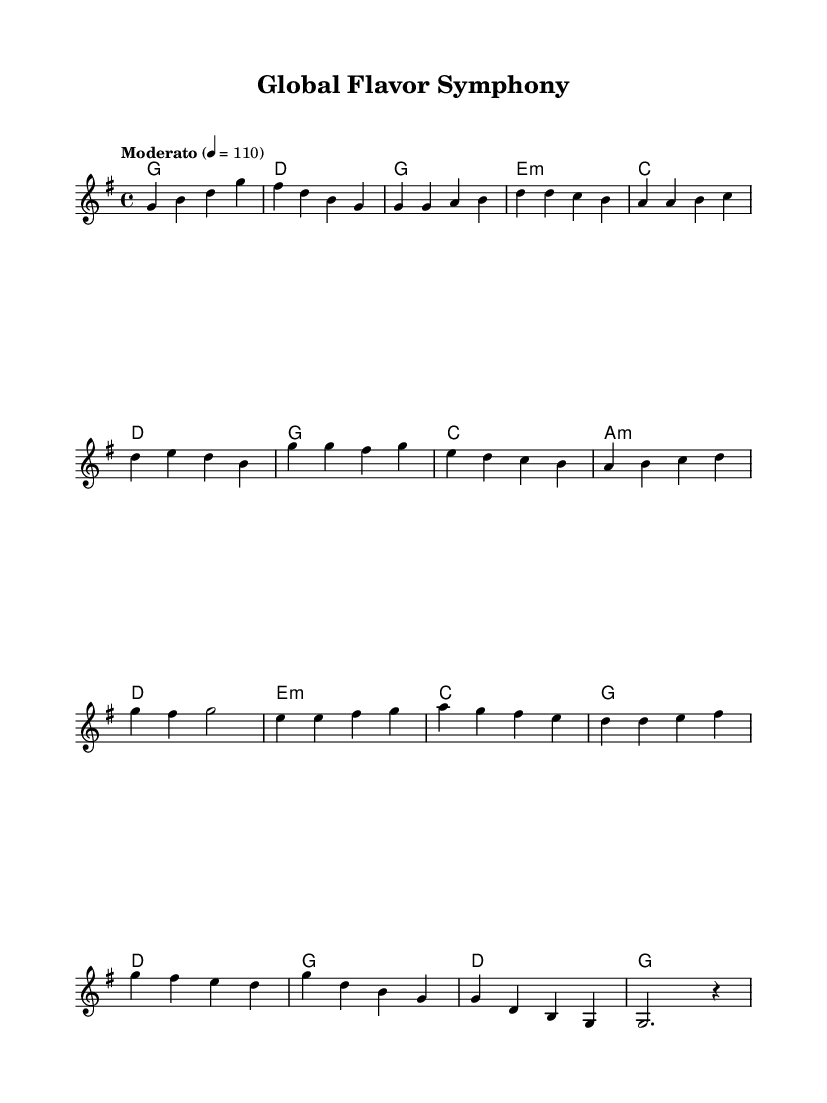What is the key signature of this music? The key signature is G major, which has one sharp (F#). You can identify this by looking at the beginning of the staff where the key signature is indicated.
Answer: G major What is the time signature of this music? The time signature is 4/4, which means there are four beats in a measure and a quarter note gets one beat. This can be observed at the beginning of the score, right after the key signature.
Answer: 4/4 What is the tempo marking for this piece? The tempo marking indicates "Moderato" with a metronome marking of 110 beats per minute. This is often shown in the score to indicate the speed at which the music should be played.
Answer: Moderato 110 How many measures are there in the chorus section? The chorus section consists of four measures, which can be counted by looking at the corresponding melody and harmony lines for that part of the song.
Answer: 4 What chord is played with the melody note 'e' in the bridge? The chord played with the melody note 'e' in the bridge is an E minor chord, which is indicated directly under the melody line in the chord section.
Answer: E minor Which section contains the phrase "g d b g" in the melody? The phrase "g d b g" is found in the outro section, as evidenced by checking the melody line at the end of the score where this sequence appears.
Answer: Outro How does the melody for the verse start? The melody for the verse starts with the note 'g' followed by another 'g', which can be seen in the first measures of the verse part of the sheet music.
Answer: g g 